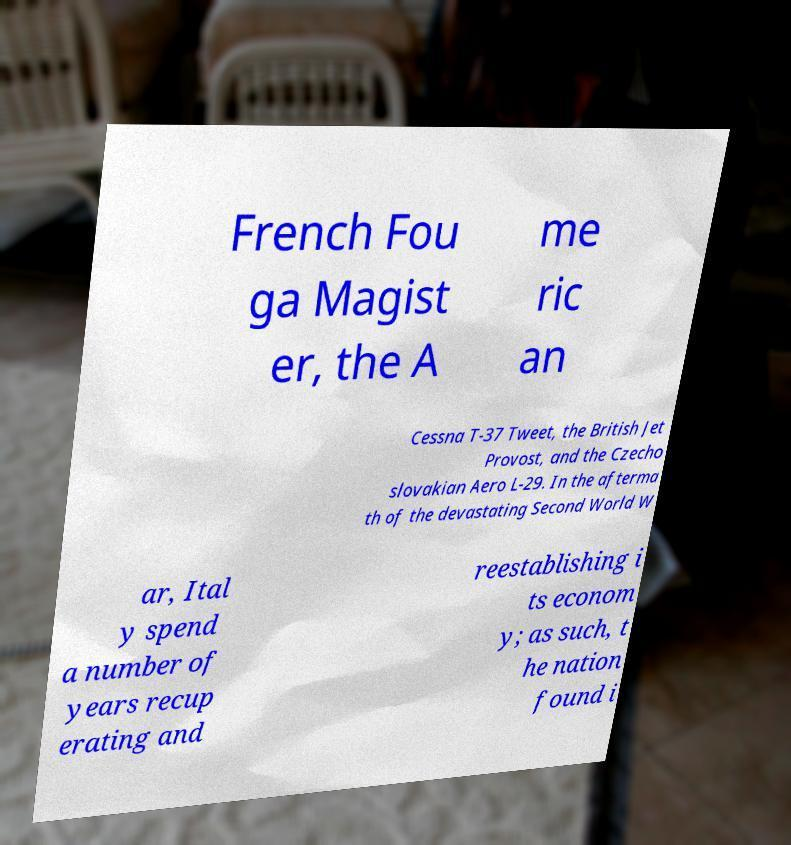Could you extract and type out the text from this image? French Fou ga Magist er, the A me ric an Cessna T-37 Tweet, the British Jet Provost, and the Czecho slovakian Aero L-29. In the afterma th of the devastating Second World W ar, Ital y spend a number of years recup erating and reestablishing i ts econom y; as such, t he nation found i 